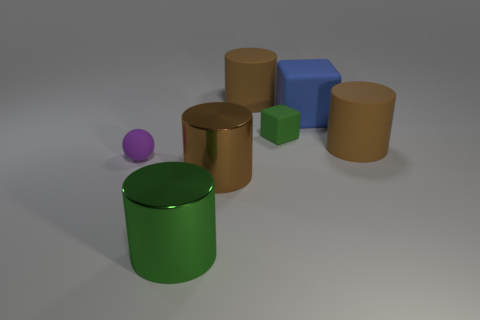Subtract all blue blocks. How many brown cylinders are left? 3 Subtract all red cylinders. Subtract all cyan cubes. How many cylinders are left? 4 Add 1 metallic objects. How many objects exist? 8 Subtract all spheres. How many objects are left? 6 Add 5 big blue spheres. How many big blue spheres exist? 5 Subtract 0 yellow blocks. How many objects are left? 7 Subtract all brown objects. Subtract all rubber balls. How many objects are left? 3 Add 3 purple matte objects. How many purple matte objects are left? 4 